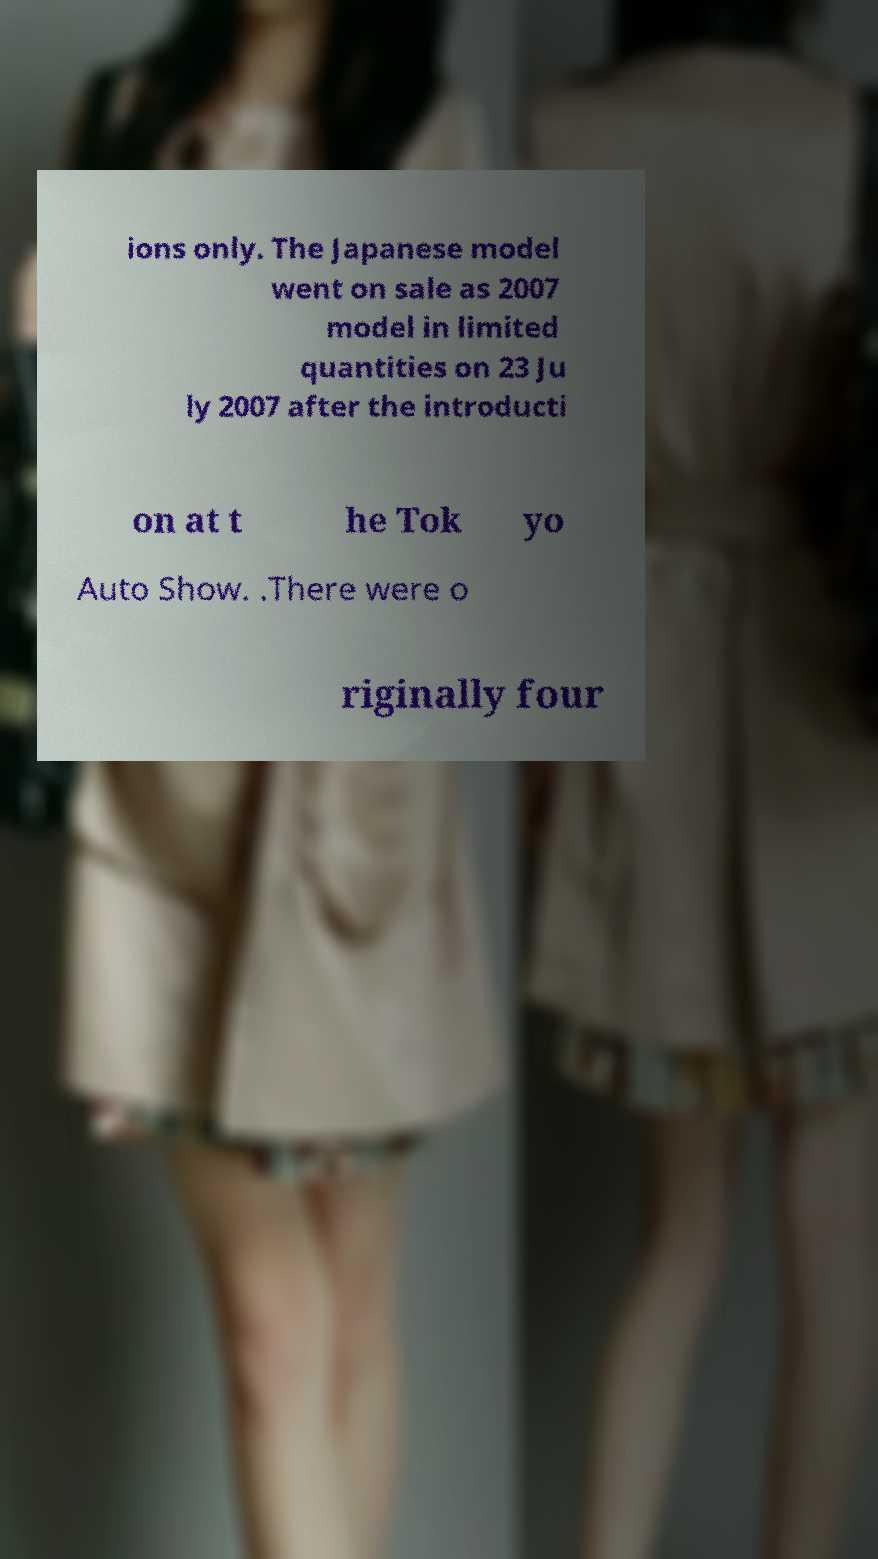Please read and relay the text visible in this image. What does it say? ions only. The Japanese model went on sale as 2007 model in limited quantities on 23 Ju ly 2007 after the introducti on at t he Tok yo Auto Show. .There were o riginally four 